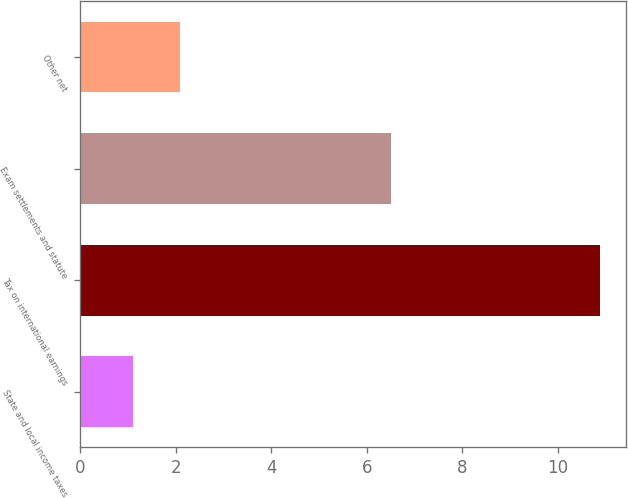Convert chart to OTSL. <chart><loc_0><loc_0><loc_500><loc_500><bar_chart><fcel>State and local income taxes<fcel>Tax on international earnings<fcel>Exam settlements and statute<fcel>Other net<nl><fcel>1.1<fcel>10.9<fcel>6.5<fcel>2.08<nl></chart> 